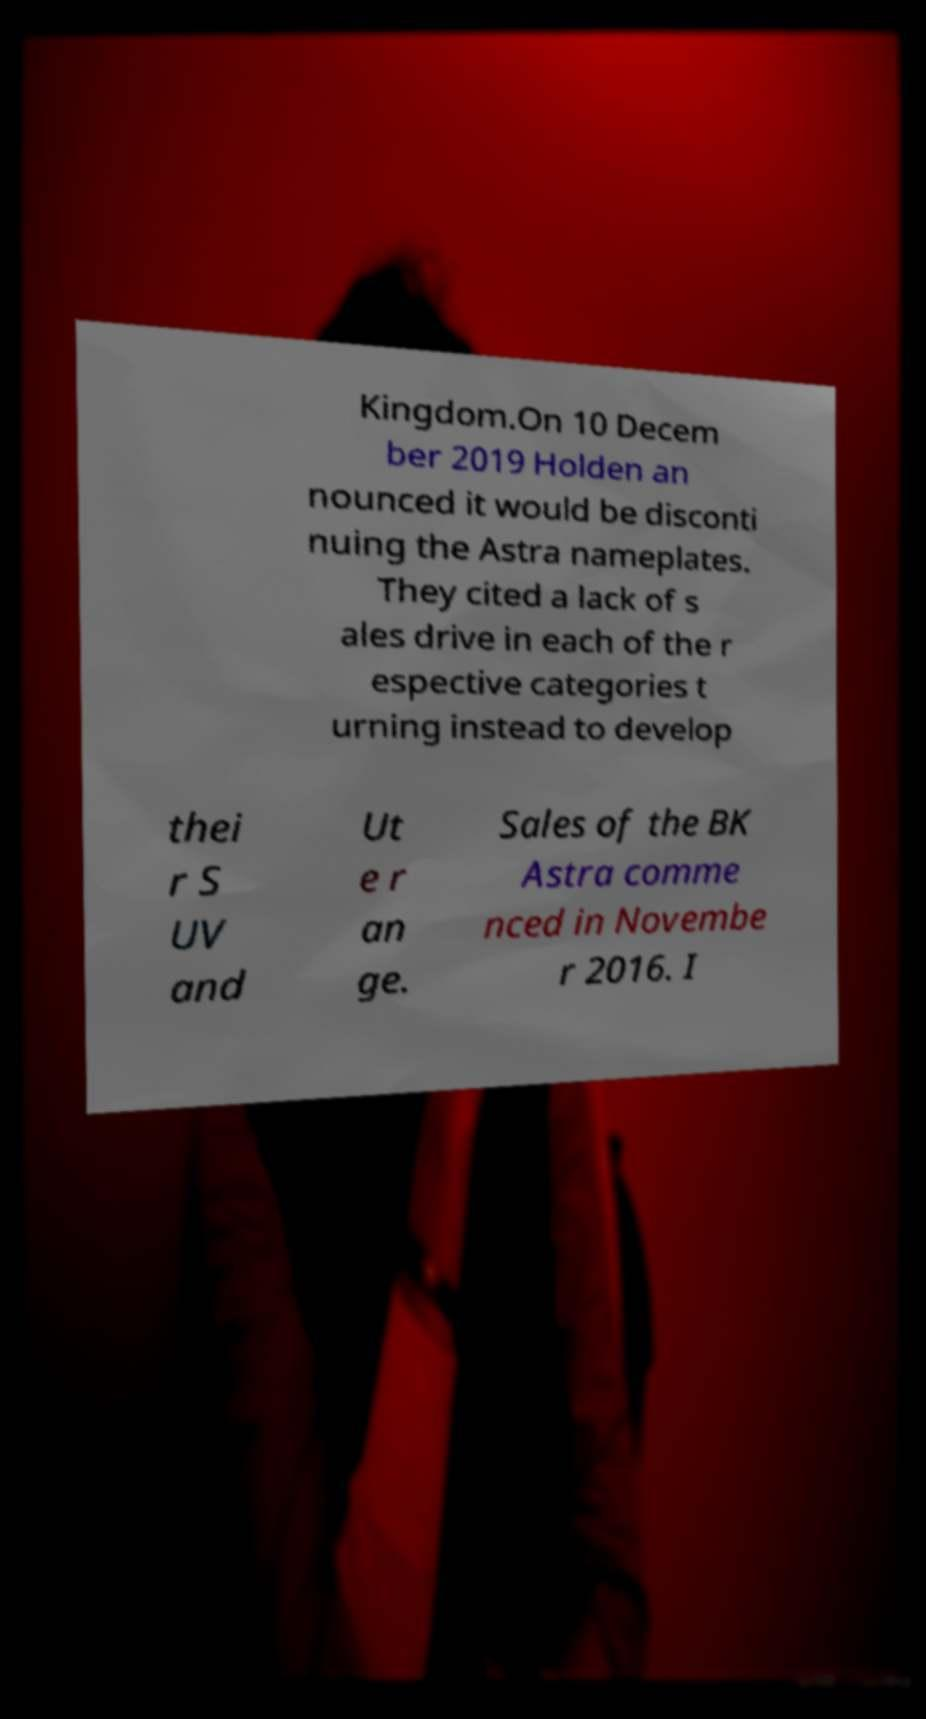Can you read and provide the text displayed in the image?This photo seems to have some interesting text. Can you extract and type it out for me? Kingdom.On 10 Decem ber 2019 Holden an nounced it would be disconti nuing the Astra nameplates. They cited a lack of s ales drive in each of the r espective categories t urning instead to develop thei r S UV and Ut e r an ge. Sales of the BK Astra comme nced in Novembe r 2016. I 